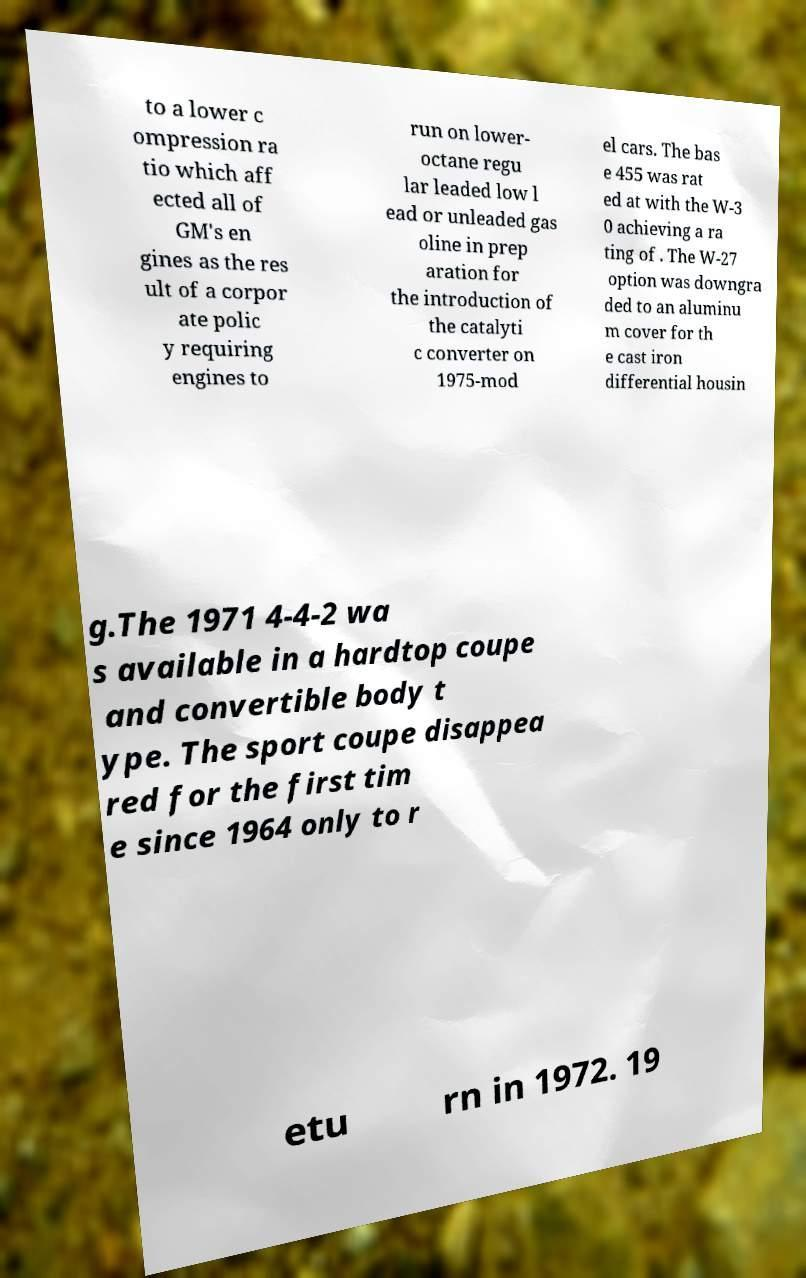For documentation purposes, I need the text within this image transcribed. Could you provide that? to a lower c ompression ra tio which aff ected all of GM's en gines as the res ult of a corpor ate polic y requiring engines to run on lower- octane regu lar leaded low l ead or unleaded gas oline in prep aration for the introduction of the catalyti c converter on 1975-mod el cars. The bas e 455 was rat ed at with the W-3 0 achieving a ra ting of . The W-27 option was downgra ded to an aluminu m cover for th e cast iron differential housin g.The 1971 4-4-2 wa s available in a hardtop coupe and convertible body t ype. The sport coupe disappea red for the first tim e since 1964 only to r etu rn in 1972. 19 